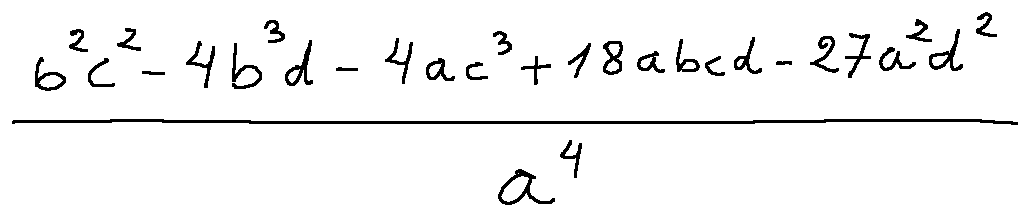Convert formula to latex. <formula><loc_0><loc_0><loc_500><loc_500>\frac { b ^ { 2 } c ^ { 2 } - 4 b ^ { 3 } d - 4 a c ^ { 3 } + 1 8 a b c d - 2 7 a ^ { 2 } d ^ { 2 } } { a ^ { 4 } }</formula> 